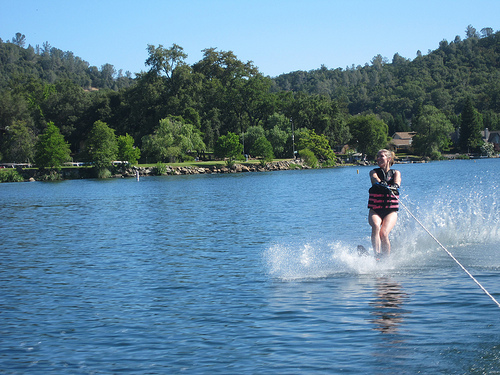What time of the day does it seem to be? The sky is clear and the sunlight appears bright, suggesting it is somewhere around midday. 